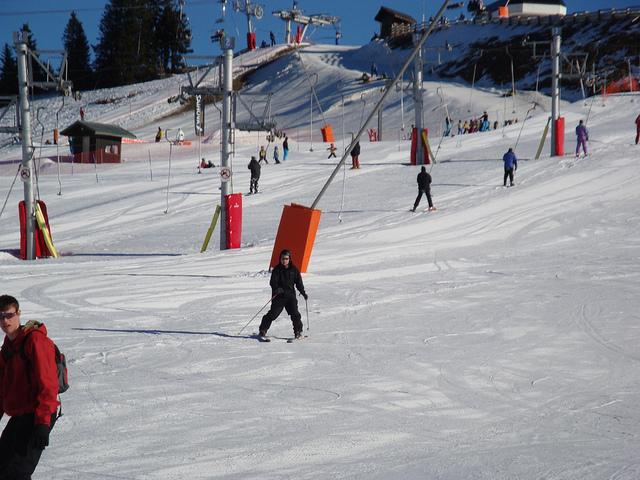Does this look like a lodge?
Be succinct. Yes. How many people are skiing?
Concise answer only. 15. What color is the pole close to the snowboarders?
Answer briefly. Gray. Do all people seem to be wearing safety gear?
Write a very short answer. No. Is it snowing?
Give a very brief answer. No. 